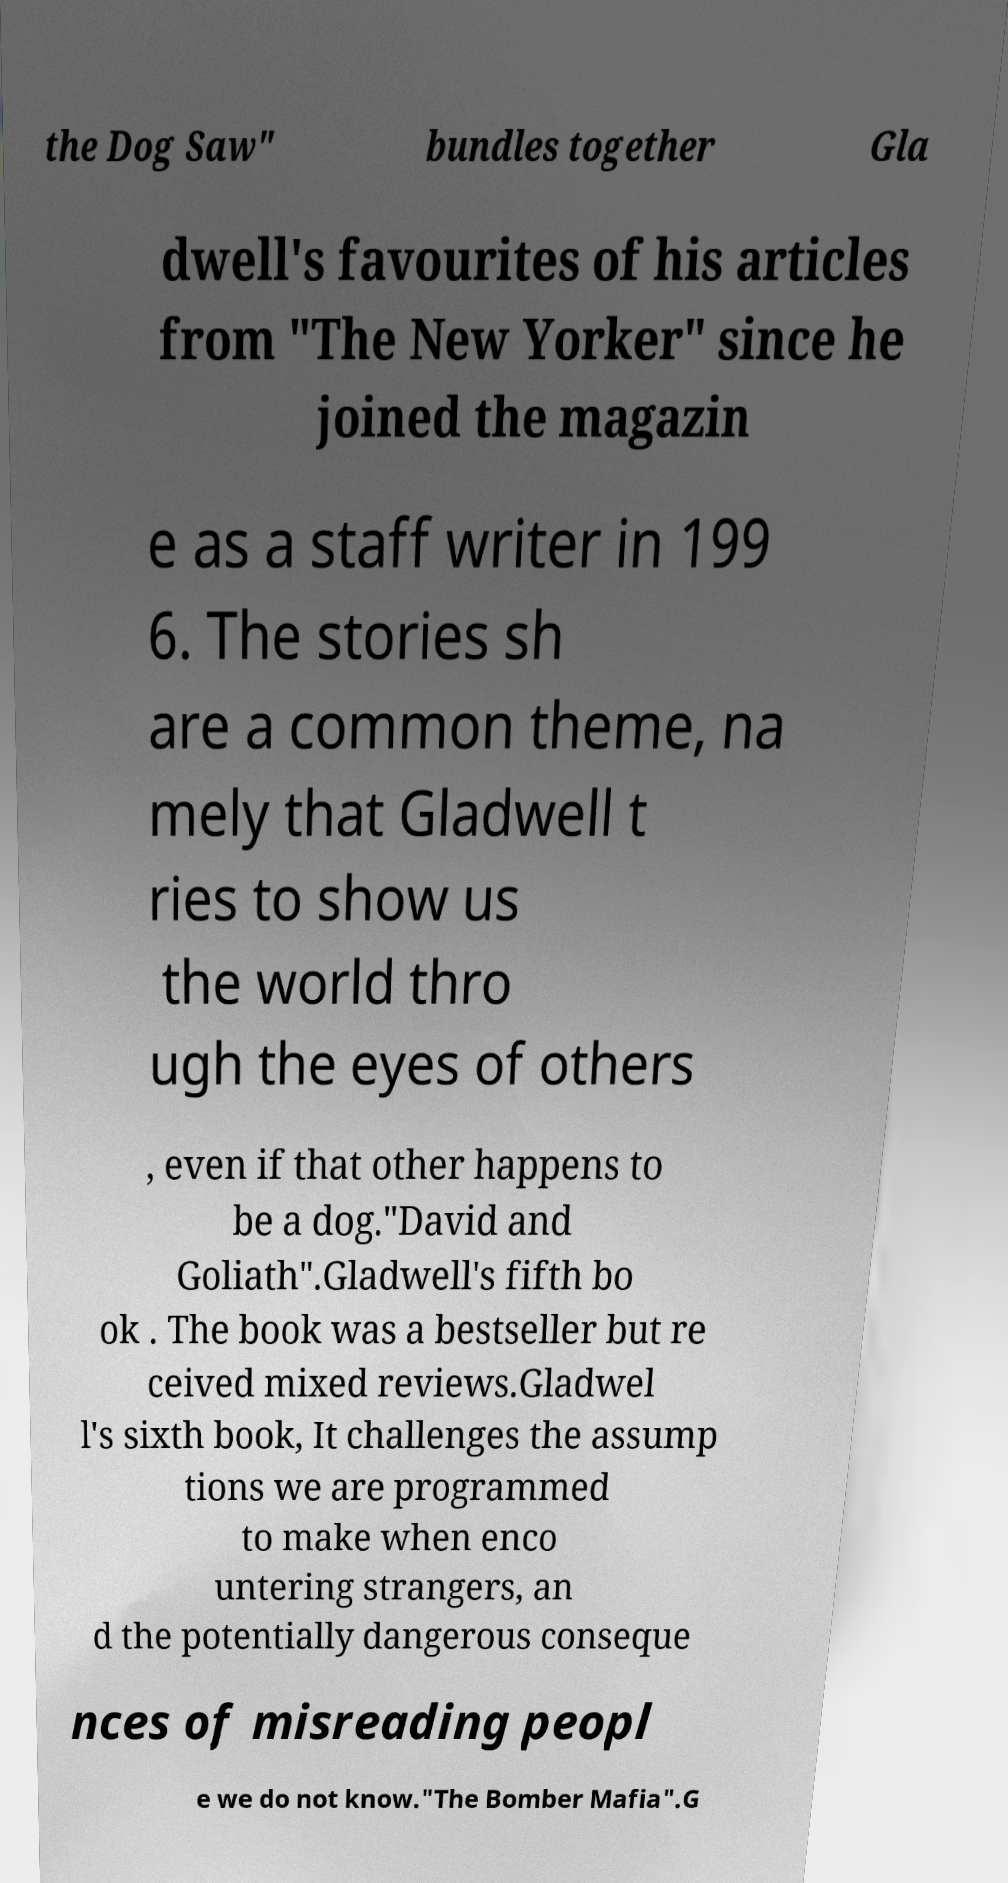There's text embedded in this image that I need extracted. Can you transcribe it verbatim? the Dog Saw" bundles together Gla dwell's favourites of his articles from "The New Yorker" since he joined the magazin e as a staff writer in 199 6. The stories sh are a common theme, na mely that Gladwell t ries to show us the world thro ugh the eyes of others , even if that other happens to be a dog."David and Goliath".Gladwell's fifth bo ok . The book was a bestseller but re ceived mixed reviews.Gladwel l's sixth book, It challenges the assump tions we are programmed to make when enco untering strangers, an d the potentially dangerous conseque nces of misreading peopl e we do not know."The Bomber Mafia".G 